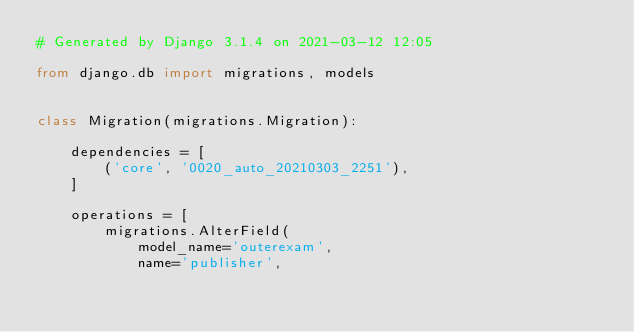<code> <loc_0><loc_0><loc_500><loc_500><_Python_># Generated by Django 3.1.4 on 2021-03-12 12:05

from django.db import migrations, models


class Migration(migrations.Migration):

    dependencies = [
        ('core', '0020_auto_20210303_2251'),
    ]

    operations = [
        migrations.AlterField(
            model_name='outerexam',
            name='publisher',</code> 